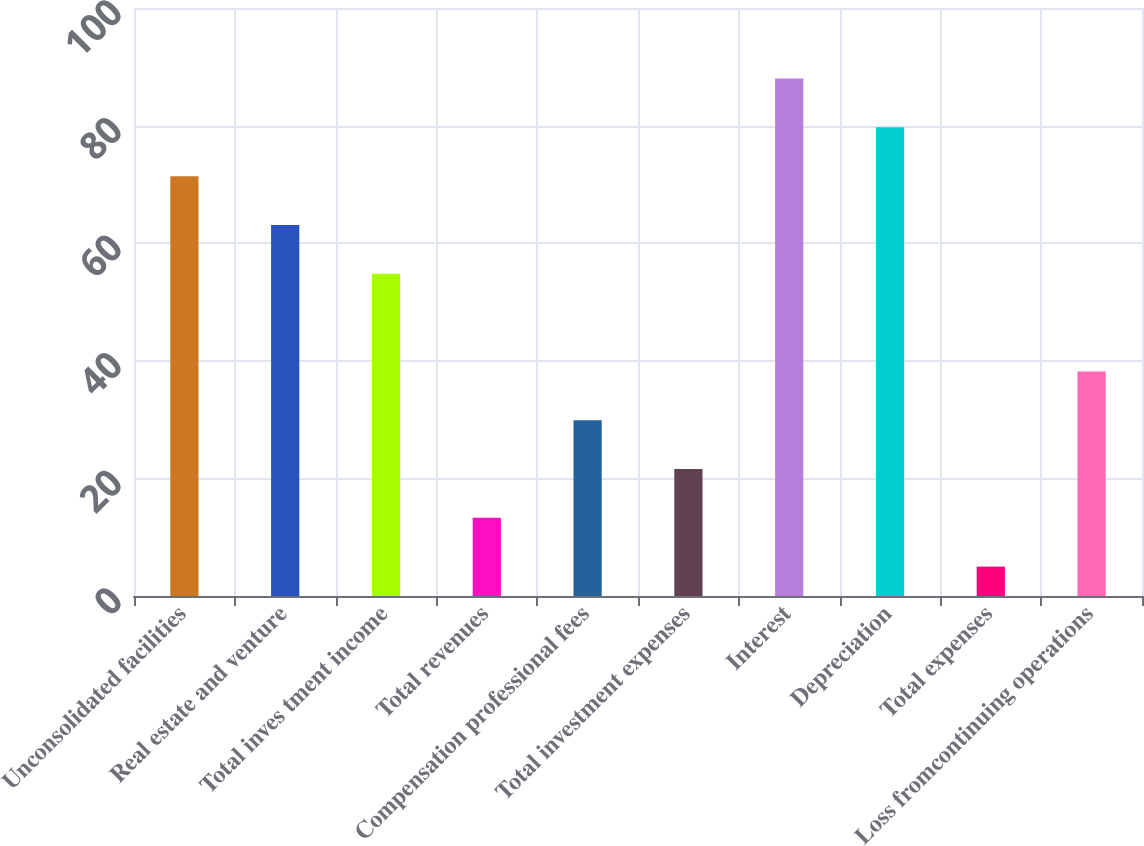<chart> <loc_0><loc_0><loc_500><loc_500><bar_chart><fcel>Unconsolidated facilities<fcel>Real estate and venture<fcel>Total inves tment income<fcel>Total revenues<fcel>Compensation professional fees<fcel>Total investment expenses<fcel>Interest<fcel>Depreciation<fcel>Total expenses<fcel>Loss fromcontinuing operations<nl><fcel>71.4<fcel>63.1<fcel>54.8<fcel>13.3<fcel>29.9<fcel>21.6<fcel>88<fcel>79.7<fcel>5<fcel>38.2<nl></chart> 